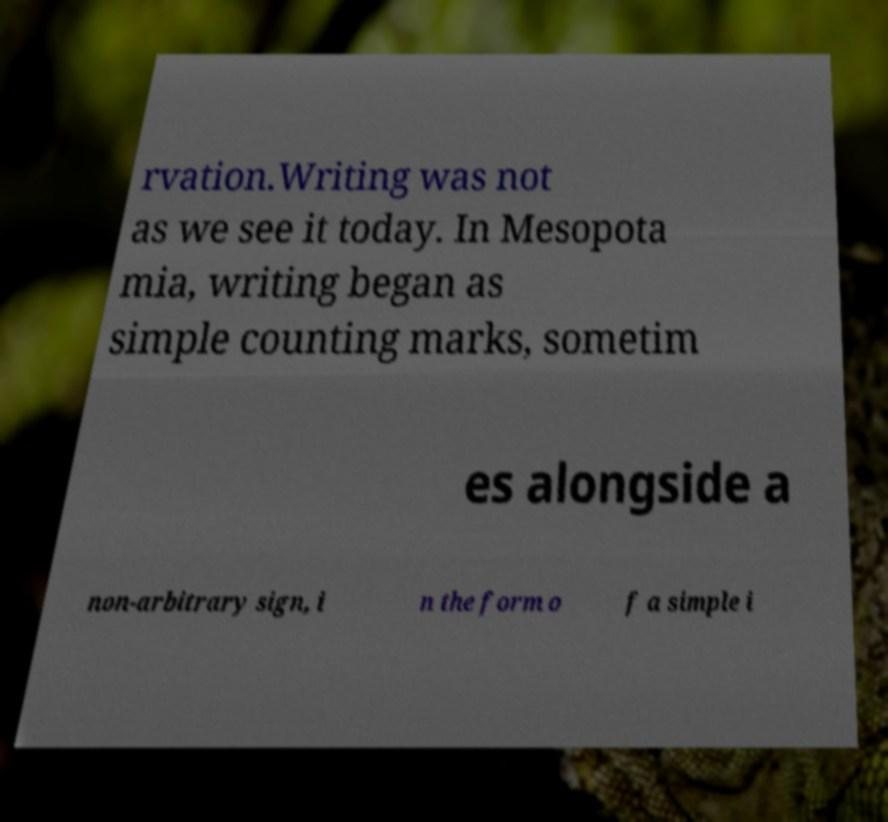Could you assist in decoding the text presented in this image and type it out clearly? rvation.Writing was not as we see it today. In Mesopota mia, writing began as simple counting marks, sometim es alongside a non-arbitrary sign, i n the form o f a simple i 